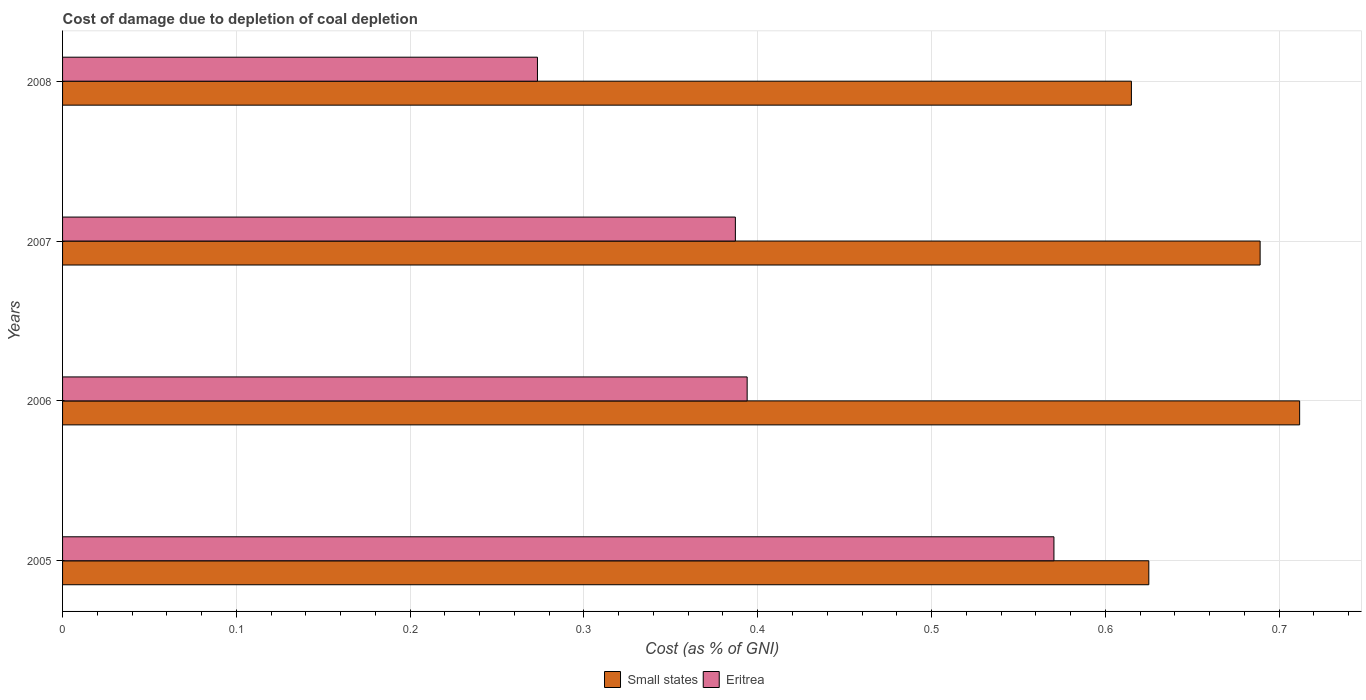How many different coloured bars are there?
Your response must be concise. 2. Are the number of bars per tick equal to the number of legend labels?
Give a very brief answer. Yes. Are the number of bars on each tick of the Y-axis equal?
Provide a short and direct response. Yes. How many bars are there on the 3rd tick from the top?
Your response must be concise. 2. In how many cases, is the number of bars for a given year not equal to the number of legend labels?
Provide a short and direct response. 0. What is the cost of damage caused due to coal depletion in Small states in 2008?
Provide a short and direct response. 0.62. Across all years, what is the maximum cost of damage caused due to coal depletion in Small states?
Ensure brevity in your answer.  0.71. Across all years, what is the minimum cost of damage caused due to coal depletion in Eritrea?
Make the answer very short. 0.27. In which year was the cost of damage caused due to coal depletion in Eritrea minimum?
Provide a short and direct response. 2008. What is the total cost of damage caused due to coal depletion in Small states in the graph?
Your response must be concise. 2.64. What is the difference between the cost of damage caused due to coal depletion in Small states in 2005 and that in 2006?
Your answer should be very brief. -0.09. What is the difference between the cost of damage caused due to coal depletion in Small states in 2008 and the cost of damage caused due to coal depletion in Eritrea in 2007?
Offer a very short reply. 0.23. What is the average cost of damage caused due to coal depletion in Small states per year?
Keep it short and to the point. 0.66. In the year 2005, what is the difference between the cost of damage caused due to coal depletion in Small states and cost of damage caused due to coal depletion in Eritrea?
Your answer should be very brief. 0.05. What is the ratio of the cost of damage caused due to coal depletion in Small states in 2005 to that in 2008?
Your response must be concise. 1.02. What is the difference between the highest and the second highest cost of damage caused due to coal depletion in Small states?
Ensure brevity in your answer.  0.02. What is the difference between the highest and the lowest cost of damage caused due to coal depletion in Small states?
Your answer should be very brief. 0.1. What does the 1st bar from the top in 2006 represents?
Offer a terse response. Eritrea. What does the 1st bar from the bottom in 2008 represents?
Ensure brevity in your answer.  Small states. How many bars are there?
Offer a terse response. 8. Are all the bars in the graph horizontal?
Give a very brief answer. Yes. How many years are there in the graph?
Keep it short and to the point. 4. Are the values on the major ticks of X-axis written in scientific E-notation?
Your response must be concise. No. Does the graph contain any zero values?
Your answer should be very brief. No. Does the graph contain grids?
Ensure brevity in your answer.  Yes. Where does the legend appear in the graph?
Offer a terse response. Bottom center. What is the title of the graph?
Provide a short and direct response. Cost of damage due to depletion of coal depletion. Does "Nigeria" appear as one of the legend labels in the graph?
Your response must be concise. No. What is the label or title of the X-axis?
Offer a very short reply. Cost (as % of GNI). What is the Cost (as % of GNI) in Small states in 2005?
Give a very brief answer. 0.63. What is the Cost (as % of GNI) of Eritrea in 2005?
Give a very brief answer. 0.57. What is the Cost (as % of GNI) in Small states in 2006?
Offer a terse response. 0.71. What is the Cost (as % of GNI) of Eritrea in 2006?
Your answer should be compact. 0.39. What is the Cost (as % of GNI) in Small states in 2007?
Offer a terse response. 0.69. What is the Cost (as % of GNI) of Eritrea in 2007?
Your response must be concise. 0.39. What is the Cost (as % of GNI) of Small states in 2008?
Offer a very short reply. 0.62. What is the Cost (as % of GNI) in Eritrea in 2008?
Give a very brief answer. 0.27. Across all years, what is the maximum Cost (as % of GNI) in Small states?
Your answer should be very brief. 0.71. Across all years, what is the maximum Cost (as % of GNI) of Eritrea?
Provide a succinct answer. 0.57. Across all years, what is the minimum Cost (as % of GNI) in Small states?
Your response must be concise. 0.62. Across all years, what is the minimum Cost (as % of GNI) in Eritrea?
Offer a terse response. 0.27. What is the total Cost (as % of GNI) in Small states in the graph?
Provide a short and direct response. 2.64. What is the total Cost (as % of GNI) in Eritrea in the graph?
Your answer should be compact. 1.62. What is the difference between the Cost (as % of GNI) in Small states in 2005 and that in 2006?
Make the answer very short. -0.09. What is the difference between the Cost (as % of GNI) in Eritrea in 2005 and that in 2006?
Offer a very short reply. 0.18. What is the difference between the Cost (as % of GNI) in Small states in 2005 and that in 2007?
Keep it short and to the point. -0.06. What is the difference between the Cost (as % of GNI) in Eritrea in 2005 and that in 2007?
Give a very brief answer. 0.18. What is the difference between the Cost (as % of GNI) of Eritrea in 2005 and that in 2008?
Offer a very short reply. 0.3. What is the difference between the Cost (as % of GNI) in Small states in 2006 and that in 2007?
Make the answer very short. 0.02. What is the difference between the Cost (as % of GNI) of Eritrea in 2006 and that in 2007?
Your response must be concise. 0.01. What is the difference between the Cost (as % of GNI) of Small states in 2006 and that in 2008?
Your answer should be very brief. 0.1. What is the difference between the Cost (as % of GNI) in Eritrea in 2006 and that in 2008?
Make the answer very short. 0.12. What is the difference between the Cost (as % of GNI) in Small states in 2007 and that in 2008?
Your answer should be compact. 0.07. What is the difference between the Cost (as % of GNI) of Eritrea in 2007 and that in 2008?
Offer a terse response. 0.11. What is the difference between the Cost (as % of GNI) in Small states in 2005 and the Cost (as % of GNI) in Eritrea in 2006?
Keep it short and to the point. 0.23. What is the difference between the Cost (as % of GNI) of Small states in 2005 and the Cost (as % of GNI) of Eritrea in 2007?
Your answer should be very brief. 0.24. What is the difference between the Cost (as % of GNI) in Small states in 2005 and the Cost (as % of GNI) in Eritrea in 2008?
Your response must be concise. 0.35. What is the difference between the Cost (as % of GNI) of Small states in 2006 and the Cost (as % of GNI) of Eritrea in 2007?
Make the answer very short. 0.32. What is the difference between the Cost (as % of GNI) in Small states in 2006 and the Cost (as % of GNI) in Eritrea in 2008?
Give a very brief answer. 0.44. What is the difference between the Cost (as % of GNI) of Small states in 2007 and the Cost (as % of GNI) of Eritrea in 2008?
Offer a terse response. 0.42. What is the average Cost (as % of GNI) in Small states per year?
Offer a very short reply. 0.66. What is the average Cost (as % of GNI) of Eritrea per year?
Give a very brief answer. 0.41. In the year 2005, what is the difference between the Cost (as % of GNI) in Small states and Cost (as % of GNI) in Eritrea?
Provide a succinct answer. 0.05. In the year 2006, what is the difference between the Cost (as % of GNI) in Small states and Cost (as % of GNI) in Eritrea?
Provide a short and direct response. 0.32. In the year 2007, what is the difference between the Cost (as % of GNI) in Small states and Cost (as % of GNI) in Eritrea?
Your response must be concise. 0.3. In the year 2008, what is the difference between the Cost (as % of GNI) in Small states and Cost (as % of GNI) in Eritrea?
Your response must be concise. 0.34. What is the ratio of the Cost (as % of GNI) in Small states in 2005 to that in 2006?
Offer a very short reply. 0.88. What is the ratio of the Cost (as % of GNI) in Eritrea in 2005 to that in 2006?
Offer a terse response. 1.45. What is the ratio of the Cost (as % of GNI) of Small states in 2005 to that in 2007?
Offer a terse response. 0.91. What is the ratio of the Cost (as % of GNI) of Eritrea in 2005 to that in 2007?
Provide a short and direct response. 1.47. What is the ratio of the Cost (as % of GNI) of Small states in 2005 to that in 2008?
Ensure brevity in your answer.  1.02. What is the ratio of the Cost (as % of GNI) of Eritrea in 2005 to that in 2008?
Your answer should be compact. 2.09. What is the ratio of the Cost (as % of GNI) of Small states in 2006 to that in 2007?
Ensure brevity in your answer.  1.03. What is the ratio of the Cost (as % of GNI) of Eritrea in 2006 to that in 2007?
Give a very brief answer. 1.02. What is the ratio of the Cost (as % of GNI) in Small states in 2006 to that in 2008?
Offer a terse response. 1.16. What is the ratio of the Cost (as % of GNI) in Eritrea in 2006 to that in 2008?
Your response must be concise. 1.44. What is the ratio of the Cost (as % of GNI) of Small states in 2007 to that in 2008?
Give a very brief answer. 1.12. What is the ratio of the Cost (as % of GNI) in Eritrea in 2007 to that in 2008?
Ensure brevity in your answer.  1.42. What is the difference between the highest and the second highest Cost (as % of GNI) of Small states?
Your response must be concise. 0.02. What is the difference between the highest and the second highest Cost (as % of GNI) of Eritrea?
Your answer should be very brief. 0.18. What is the difference between the highest and the lowest Cost (as % of GNI) of Small states?
Your response must be concise. 0.1. What is the difference between the highest and the lowest Cost (as % of GNI) in Eritrea?
Offer a terse response. 0.3. 